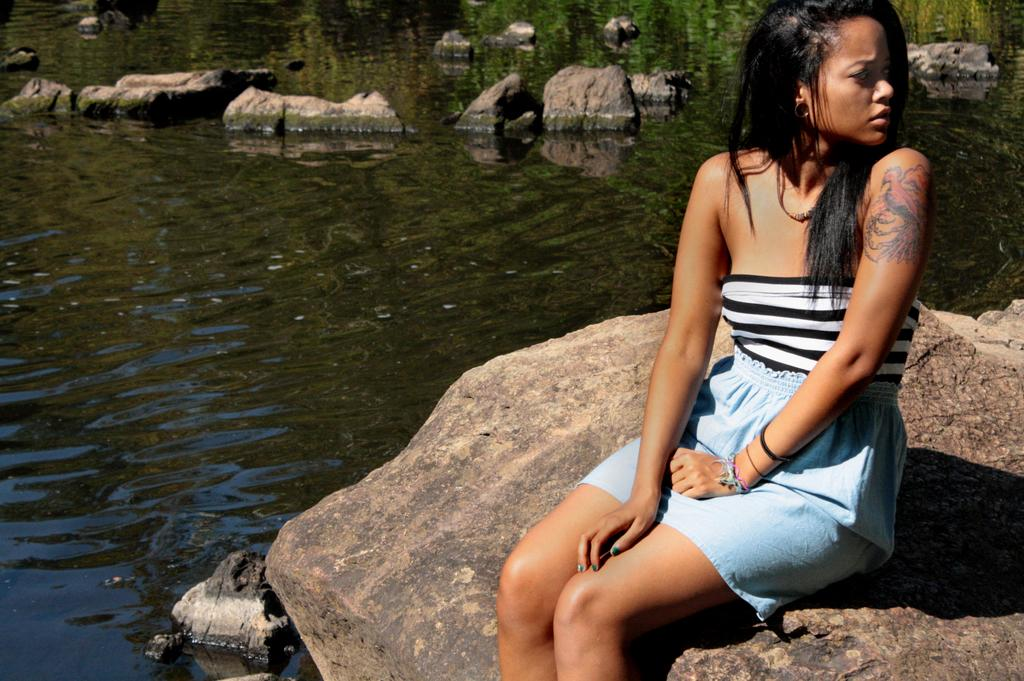Who is the main subject in the picture? There is a woman in the picture. What is the woman doing in the image? The woman is sitting on a rock. Where is the woman located in the image? The woman is near the water. What can be seen on the woman's hand? The woman has a tattoo on her hand. What type of natural feature is visible in the water? There are rocks visible in the water. What type of beef is being cooked on the record in the image? There is no beef or record present in the image. Can you tell me how many mountains are visible in the image? There are no mountains visible in the image. 